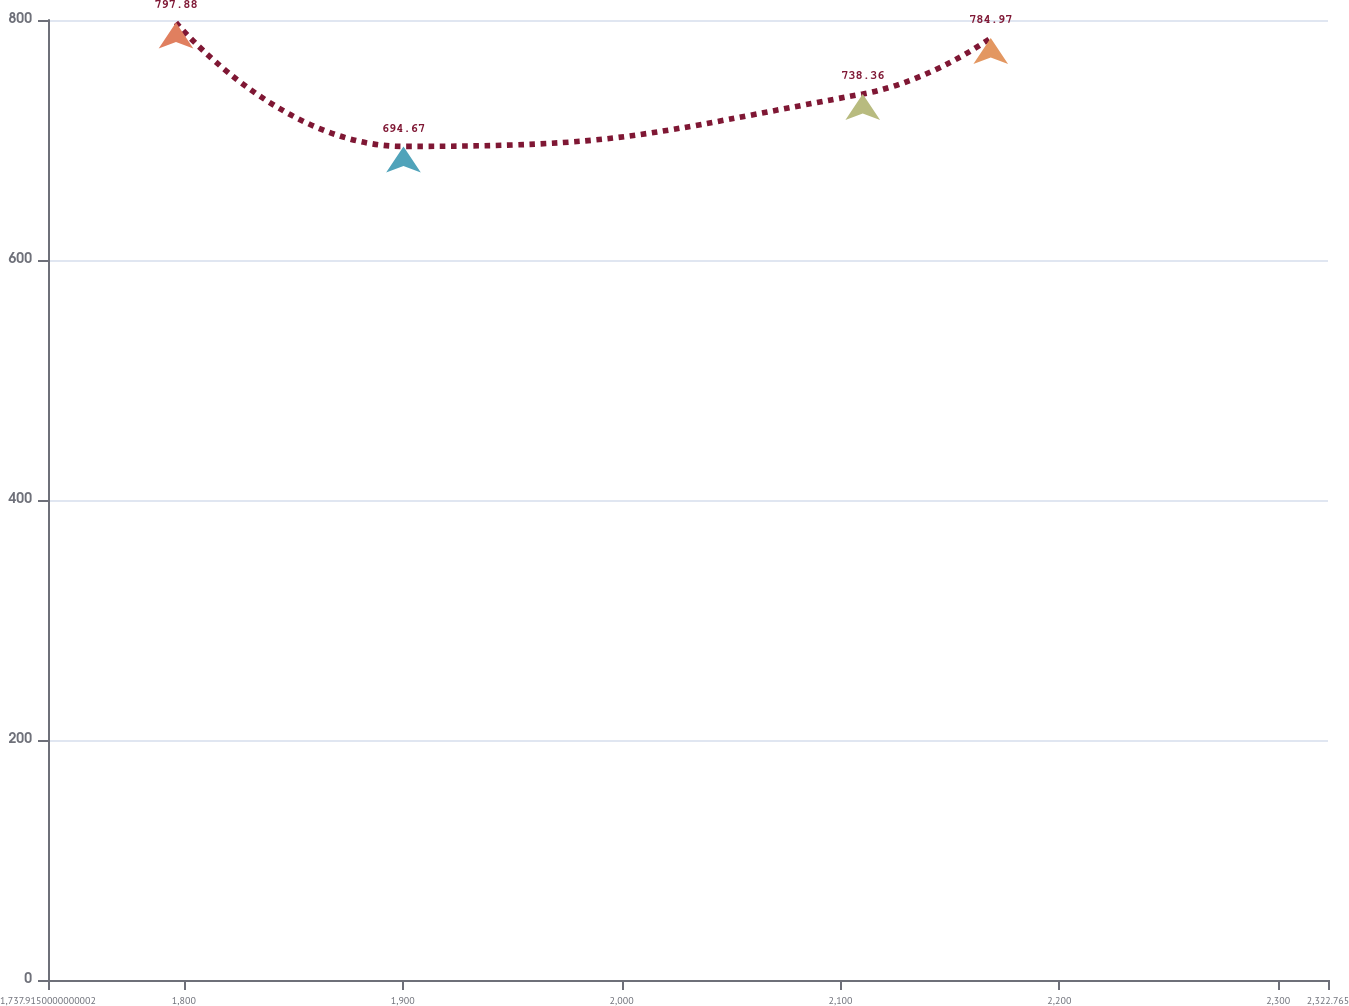Convert chart to OTSL. <chart><loc_0><loc_0><loc_500><loc_500><line_chart><ecel><fcel>Unnamed: 1<nl><fcel>1796.4<fcel>797.88<nl><fcel>1900.34<fcel>694.67<nl><fcel>2110.18<fcel>738.36<nl><fcel>2168.66<fcel>784.97<nl><fcel>2381.25<fcel>823.75<nl></chart> 